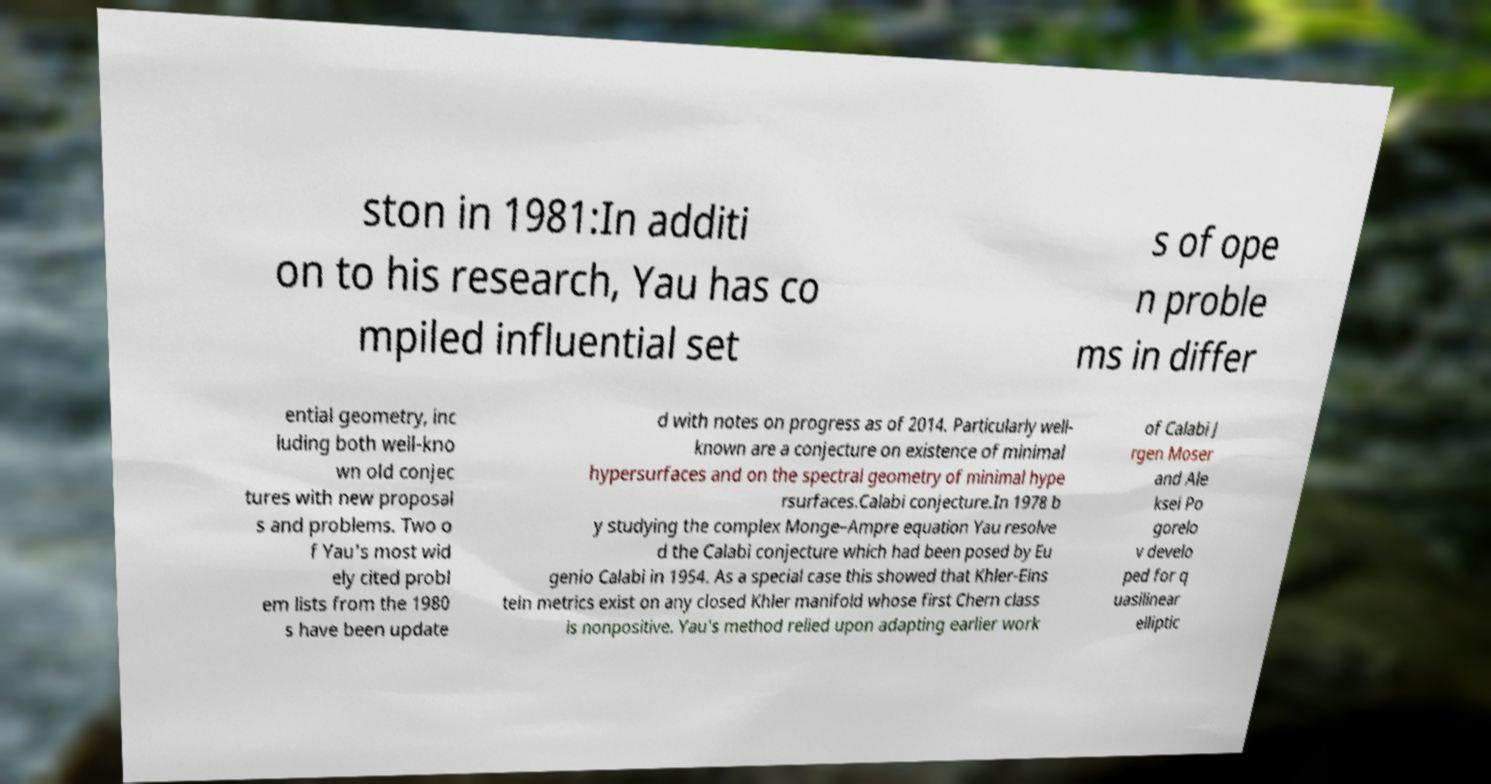I need the written content from this picture converted into text. Can you do that? ston in 1981:In additi on to his research, Yau has co mpiled influential set s of ope n proble ms in differ ential geometry, inc luding both well-kno wn old conjec tures with new proposal s and problems. Two o f Yau's most wid ely cited probl em lists from the 1980 s have been update d with notes on progress as of 2014. Particularly well- known are a conjecture on existence of minimal hypersurfaces and on the spectral geometry of minimal hype rsurfaces.Calabi conjecture.In 1978 b y studying the complex Monge–Ampre equation Yau resolve d the Calabi conjecture which had been posed by Eu genio Calabi in 1954. As a special case this showed that Khler-Eins tein metrics exist on any closed Khler manifold whose first Chern class is nonpositive. Yau's method relied upon adapting earlier work of Calabi J rgen Moser and Ale ksei Po gorelo v develo ped for q uasilinear elliptic 